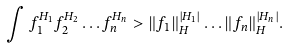<formula> <loc_0><loc_0><loc_500><loc_500>\int f _ { 1 } ^ { H _ { 1 } } f _ { 2 } ^ { H _ { 2 } } \dots f _ { n } ^ { H _ { n } } > \| f _ { 1 } \| _ { H } ^ { | H _ { 1 } | } \dots \| f _ { n } \| _ { H } ^ { | H _ { n } | } .</formula> 